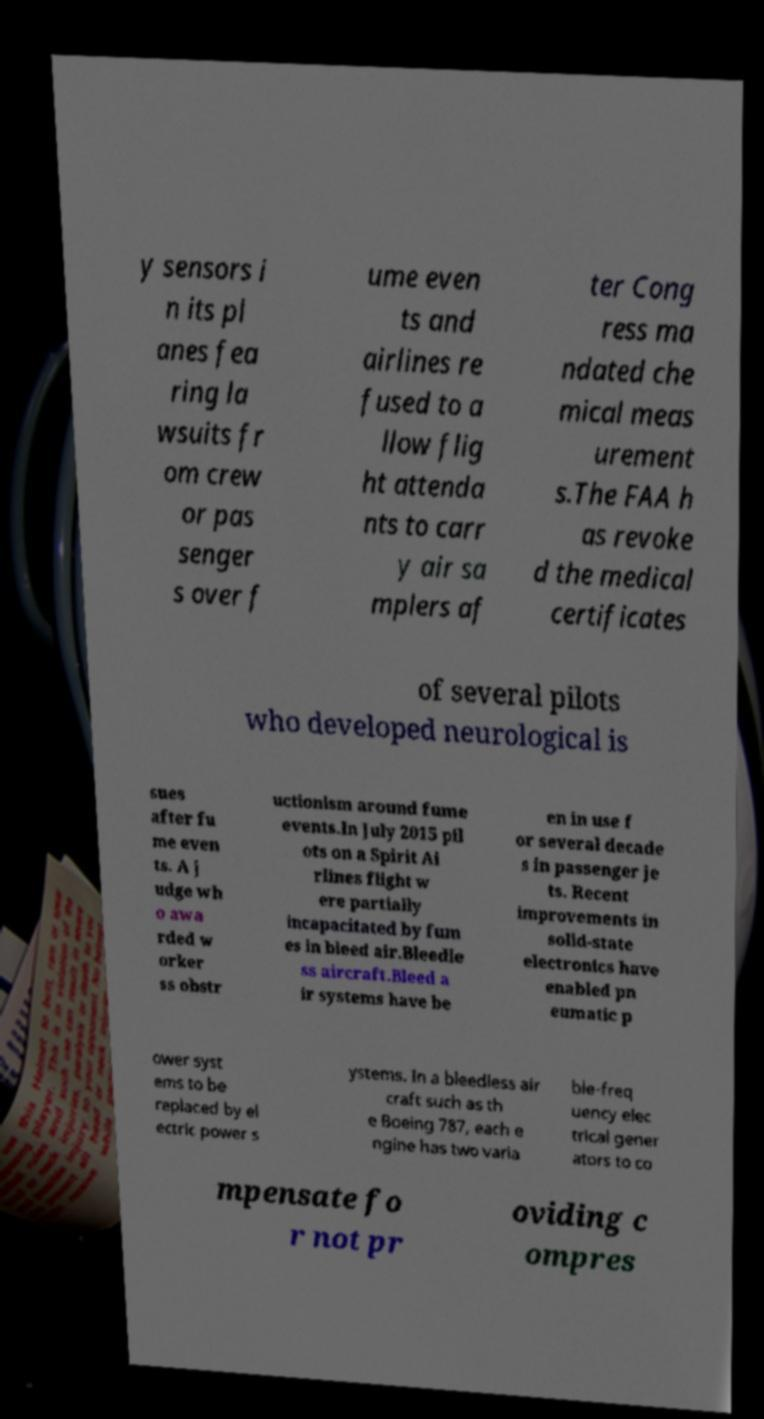For documentation purposes, I need the text within this image transcribed. Could you provide that? y sensors i n its pl anes fea ring la wsuits fr om crew or pas senger s over f ume even ts and airlines re fused to a llow flig ht attenda nts to carr y air sa mplers af ter Cong ress ma ndated che mical meas urement s.The FAA h as revoke d the medical certificates of several pilots who developed neurological is sues after fu me even ts. A j udge wh o awa rded w orker ss obstr uctionism around fume events.In July 2015 pil ots on a Spirit Ai rlines flight w ere partially incapacitated by fum es in bleed air.Bleedle ss aircraft.Bleed a ir systems have be en in use f or several decade s in passenger je ts. Recent improvements in solid-state electronics have enabled pn eumatic p ower syst ems to be replaced by el ectric power s ystems. In a bleedless air craft such as th e Boeing 787, each e ngine has two varia ble-freq uency elec trical gener ators to co mpensate fo r not pr oviding c ompres 